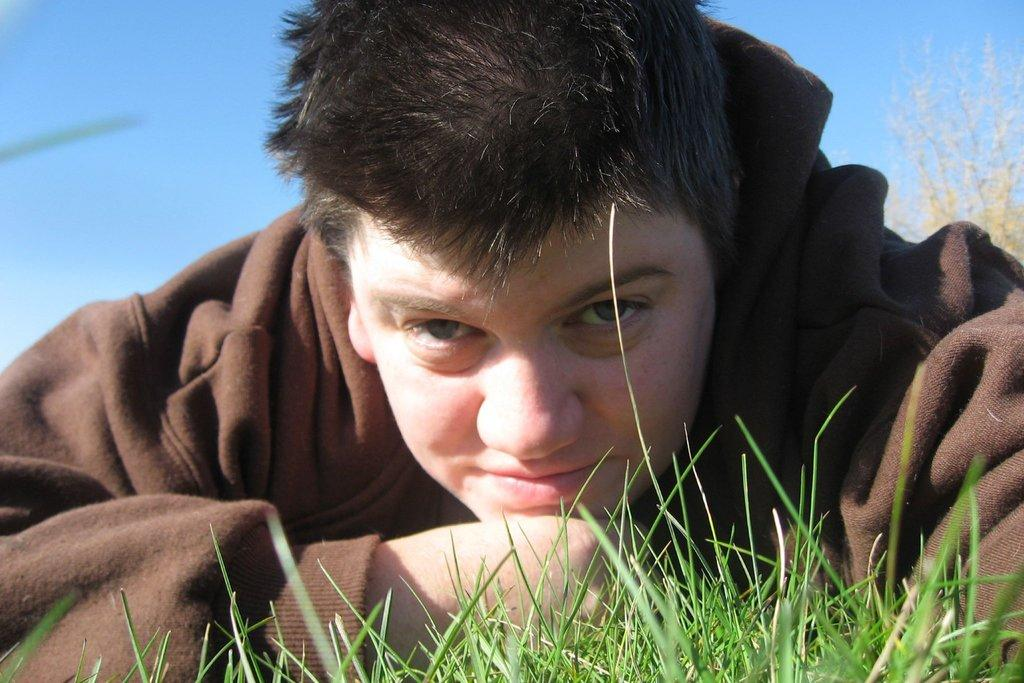Who or what is the main subject in the center of the image? There is a person in the center of the image. What type of ground is visible at the bottom of the image? There is grass at the bottom of the image. What can be seen in the background of the image? There are plants and the sky visible in the background of the image. What type of jam is being spread on the potato in the image? There is no jam or potato present in the image. 